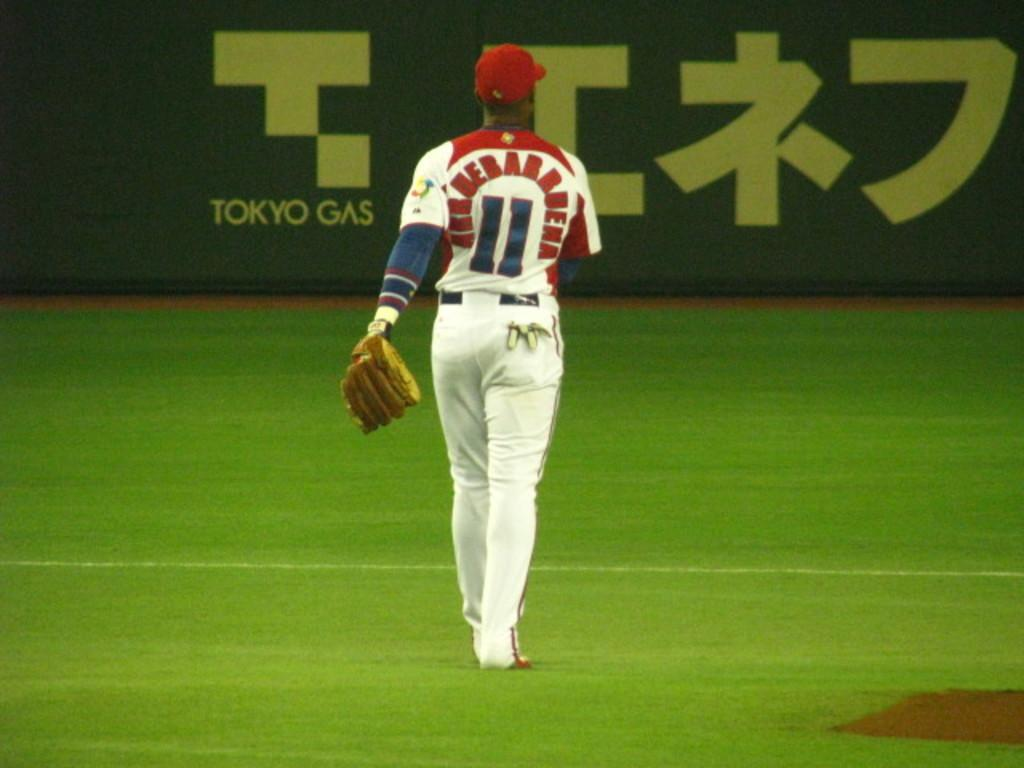<image>
Give a short and clear explanation of the subsequent image. The player here is wearing the number 11 